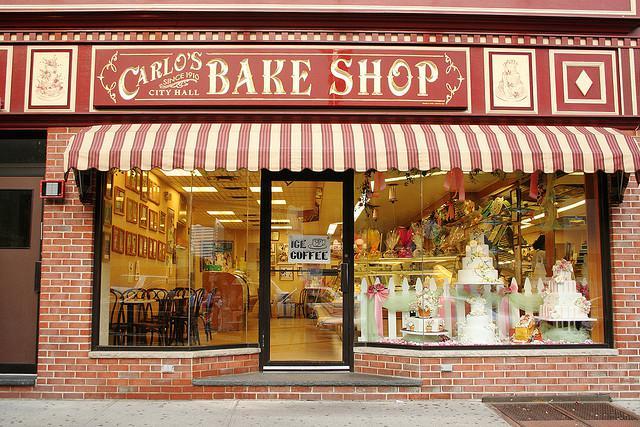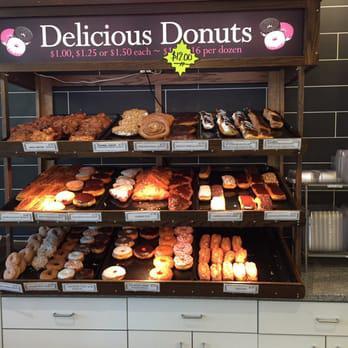The first image is the image on the left, the second image is the image on the right. Considering the images on both sides, is "There is a shoppe entrance with a striped awning." valid? Answer yes or no. Yes. 